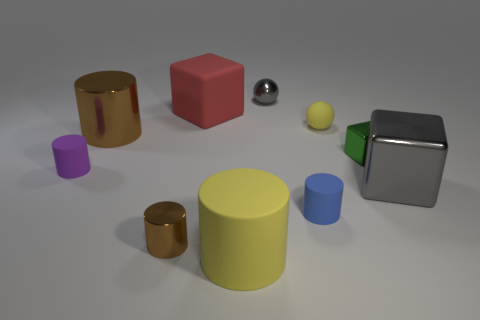Are there any tiny yellow balls that are in front of the brown metallic cylinder to the left of the metal cylinder on the right side of the big brown cylinder?
Your response must be concise. No. Do the rubber sphere and the gray shiny block have the same size?
Your response must be concise. No. Are there an equal number of big shiny cylinders that are right of the green block and small yellow rubber spheres that are on the left side of the purple object?
Your answer should be compact. Yes. There is a tiny metal thing in front of the purple matte cylinder; what is its shape?
Offer a very short reply. Cylinder. What shape is the green thing that is the same size as the metallic sphere?
Ensure brevity in your answer.  Cube. The large cylinder in front of the shiny cube that is in front of the rubber cylinder that is left of the large brown thing is what color?
Offer a terse response. Yellow. Do the big red rubber object and the small blue thing have the same shape?
Your answer should be very brief. No. Is the number of shiny cylinders that are to the right of the small purple matte thing the same as the number of small balls?
Your answer should be very brief. Yes. How many other things are the same material as the small block?
Your answer should be compact. 4. There is a gray object that is behind the red cube; does it have the same size as the yellow thing in front of the small blue cylinder?
Your answer should be very brief. No. 